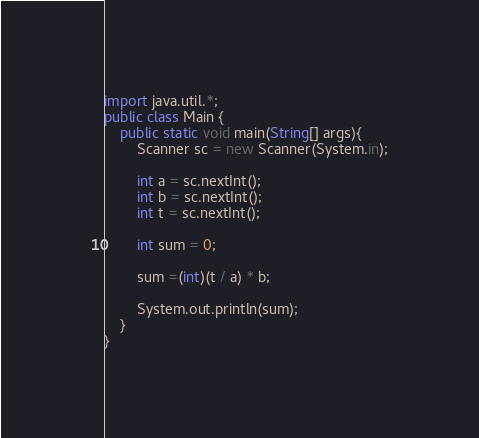<code> <loc_0><loc_0><loc_500><loc_500><_JavaScript_>import java.util.*;
public class Main {
	public static void main(String[] args){
		Scanner sc = new Scanner(System.in);

		int a = sc.nextInt();
		int b = sc.nextInt();
		int t = sc.nextInt();

		int sum = 0;

		sum =(int)(t / a) * b;

		System.out.println(sum);
	}
}
</code> 